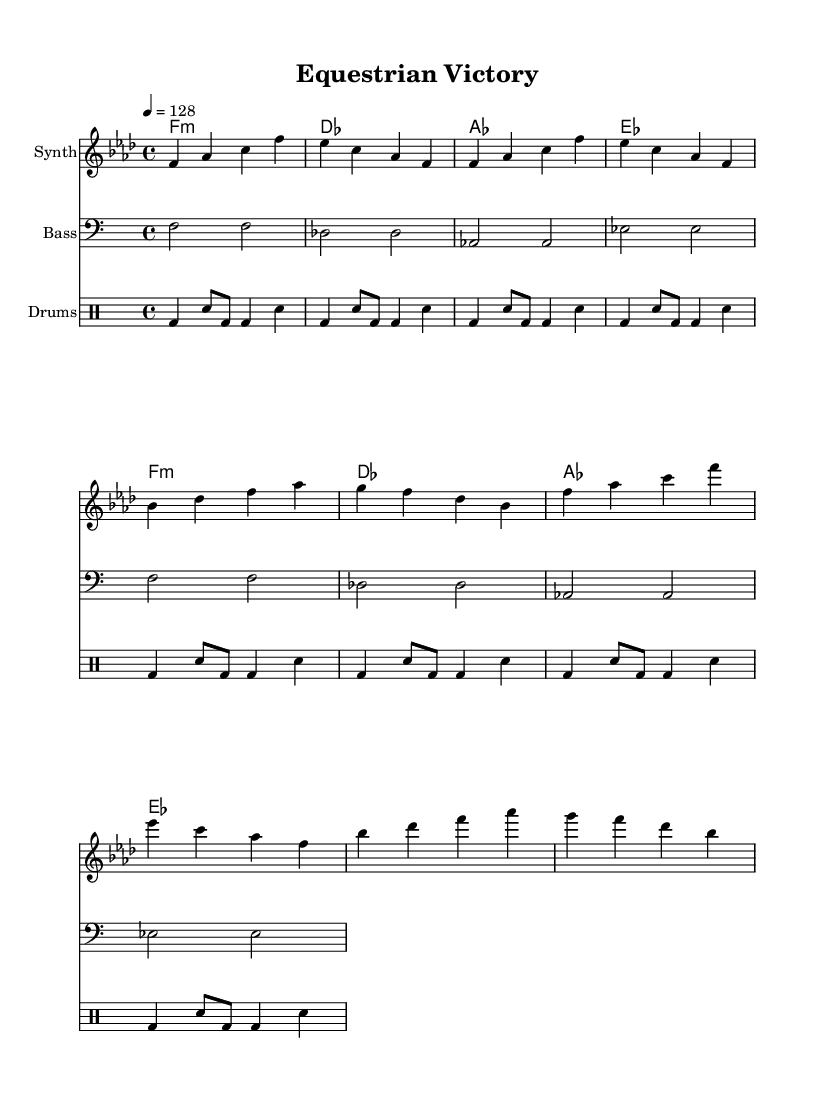What is the key signature of this music? The key signature is F minor, which has four flats (B♭, E♭, A♭, and D♭). This is determined from the key indicated at the beginning of the sheet music.
Answer: F minor What is the time signature of the piece? The time signature is 4/4, which is shown at the beginning of the sheet music. This means there are four beats in each measure and a quarter note receives one beat.
Answer: 4/4 What is the tempo marking of the piece? The tempo marking indicates 128 beats per minute, which is displayed as "4 = 128". This means the quarter note is played at 128 beats per minute.
Answer: 128 How many measures are in the chorus section? There are four measures in the chorus section, evident from counting the measures in the chorus section of the sheet music.
Answer: 4 What is the instrument type used for the main melody? The main melody is played on a synthesizer, as indicated by the instrument name above the staff containing the melody.
Answer: Synth What type of musical patterns do the drums use? The drum patterns consist of a kick drum and snare drum, as shown in the drummode section of the sheet music which includes kick and snare notations.
Answer: Kick and snare What is the harmonic progression used in this piece? The harmonic progression is F minor, D♭, A♭, and E♭, which is followed through the chordmode section where each chord is displayed as it progresses.
Answer: F minor, D♭, A♭, E♭ 